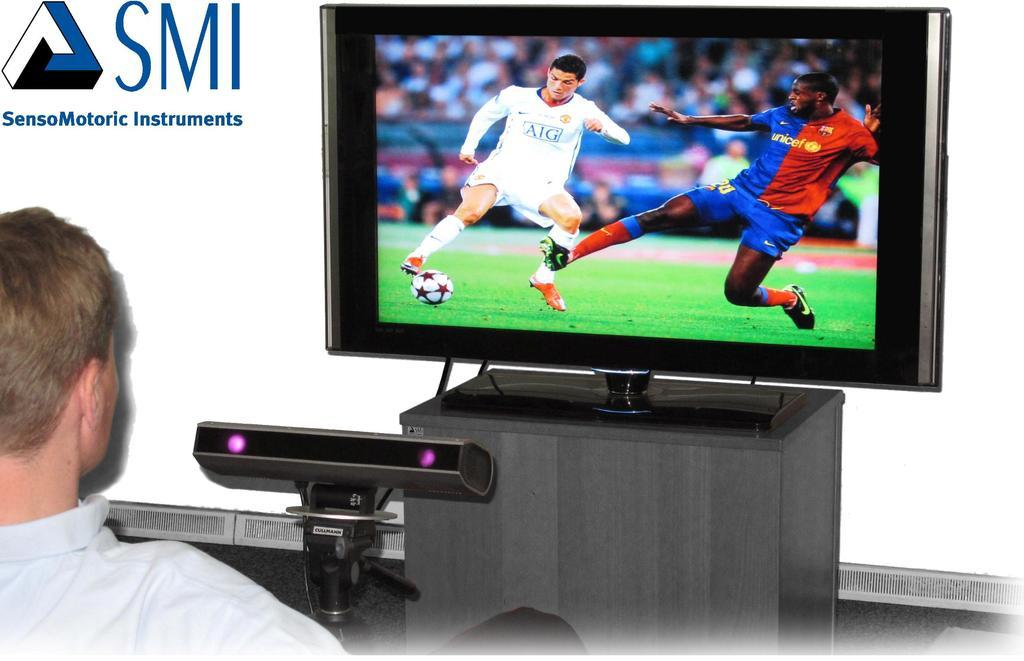<image>
Describe the image concisely. A graphic that reads SensoMotoric Instruments next to a TV showing a soccer match 